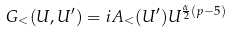<formula> <loc_0><loc_0><loc_500><loc_500>G _ { < } ( U , U ^ { \prime } ) = i A _ { < } ( U ^ { \prime } ) U ^ { \frac { \alpha } { 2 } ( p - 5 ) }</formula> 